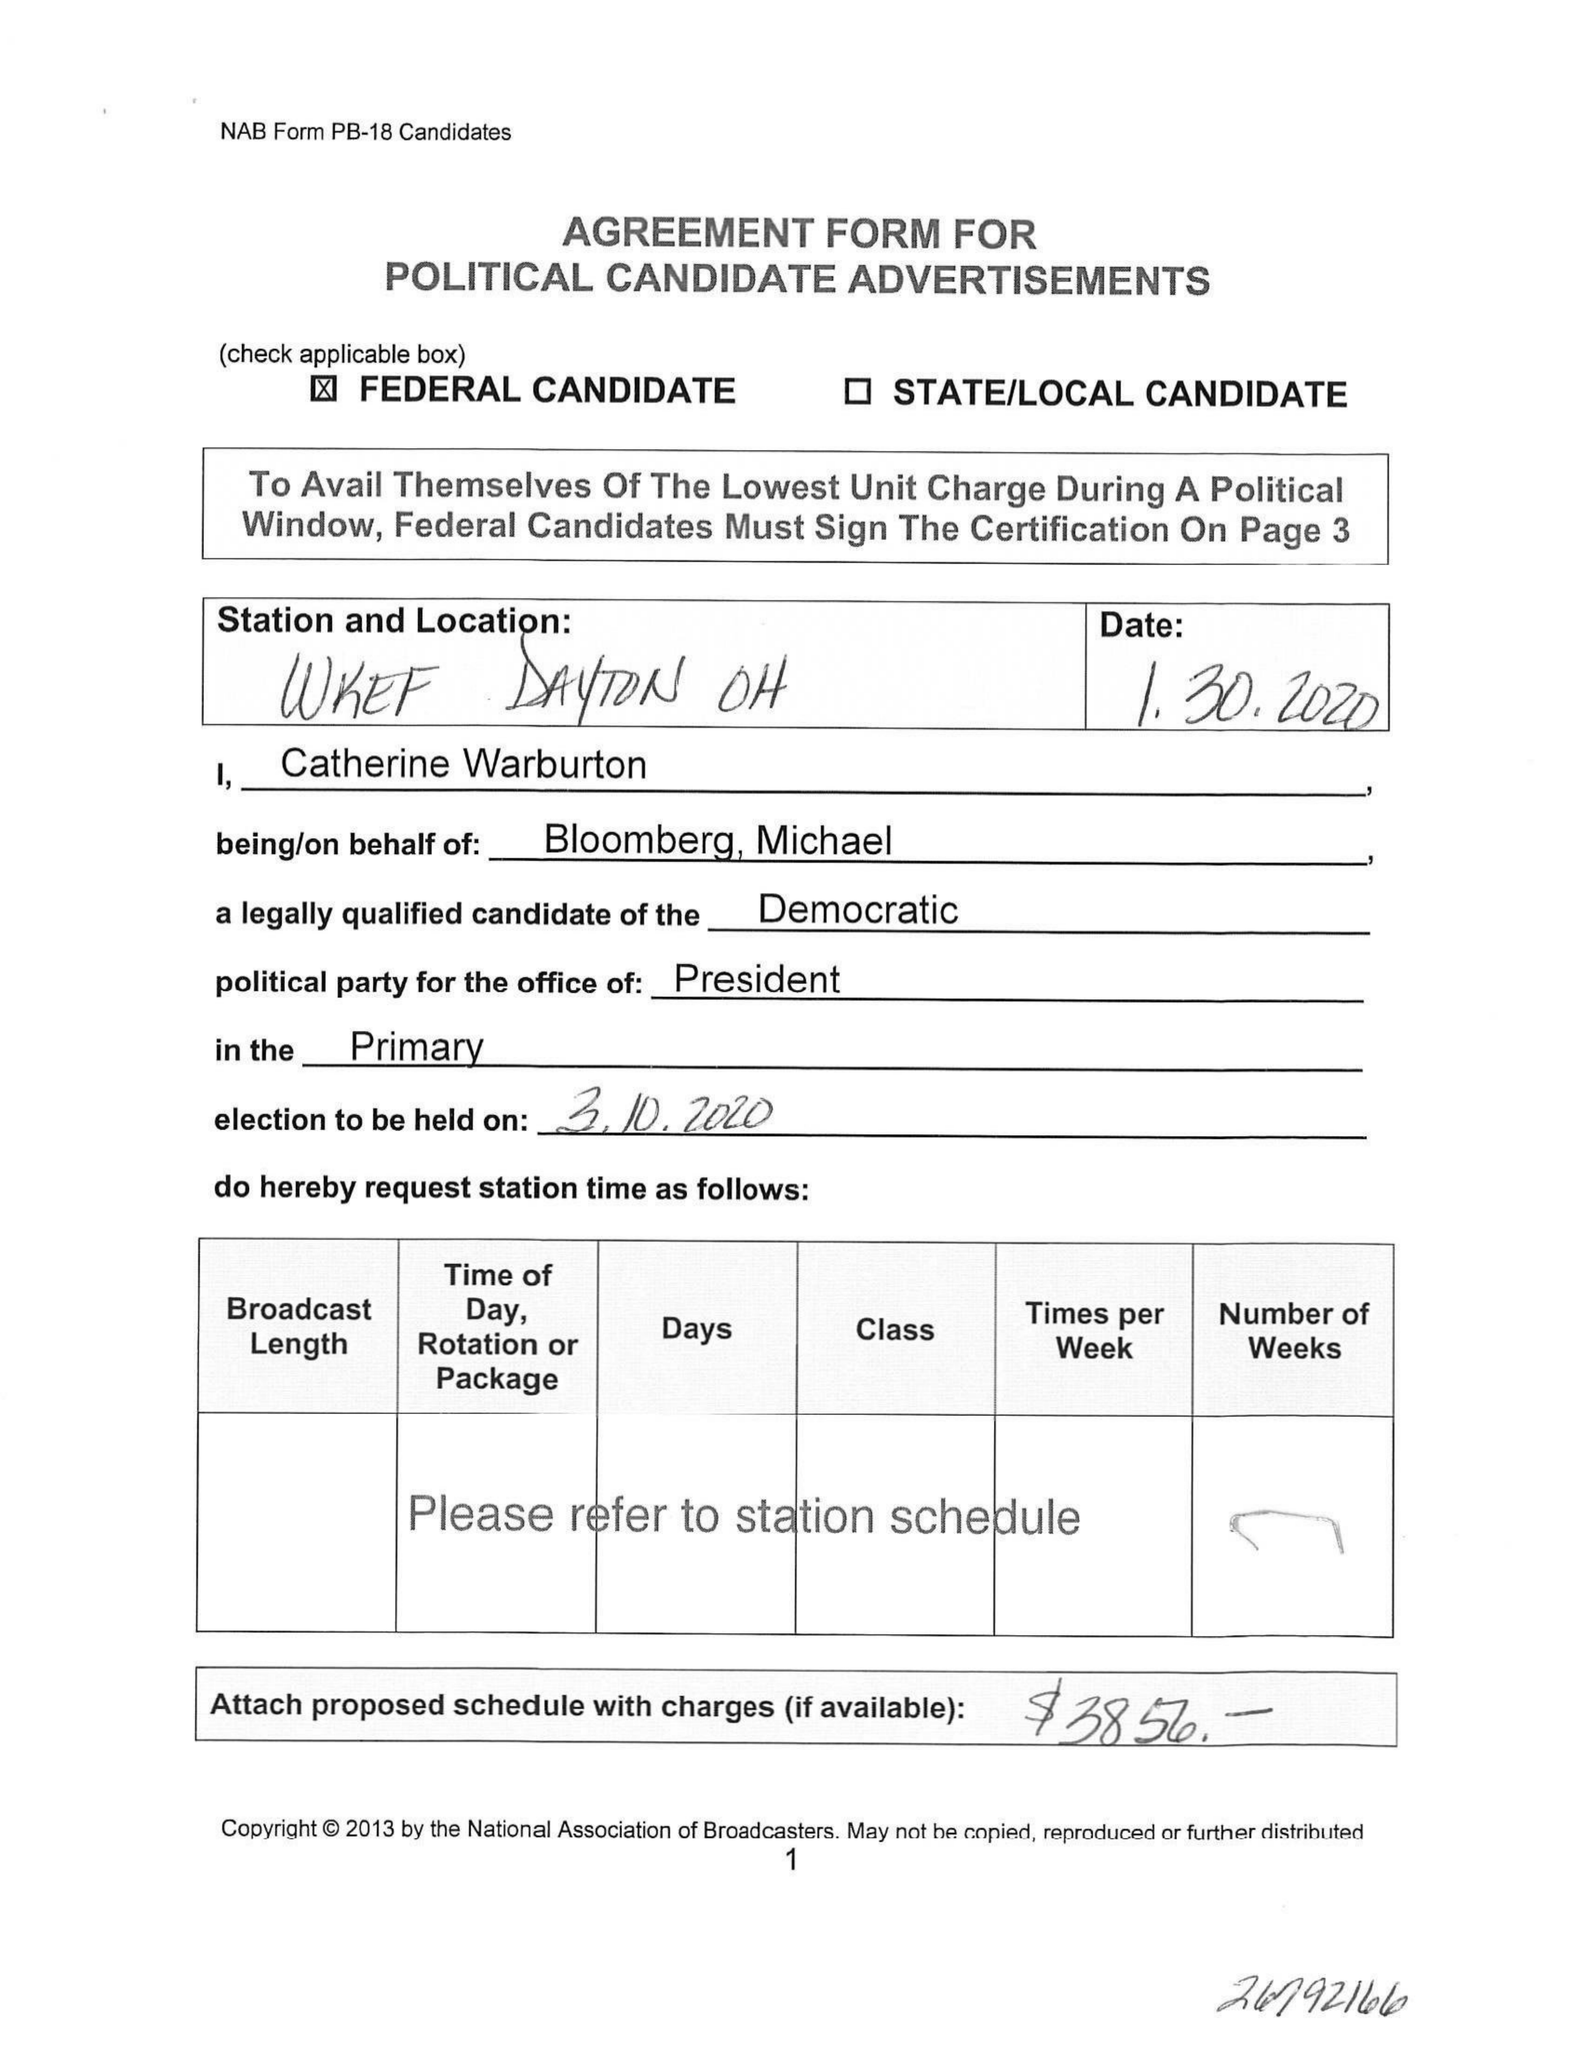What is the value for the flight_from?
Answer the question using a single word or phrase. None 